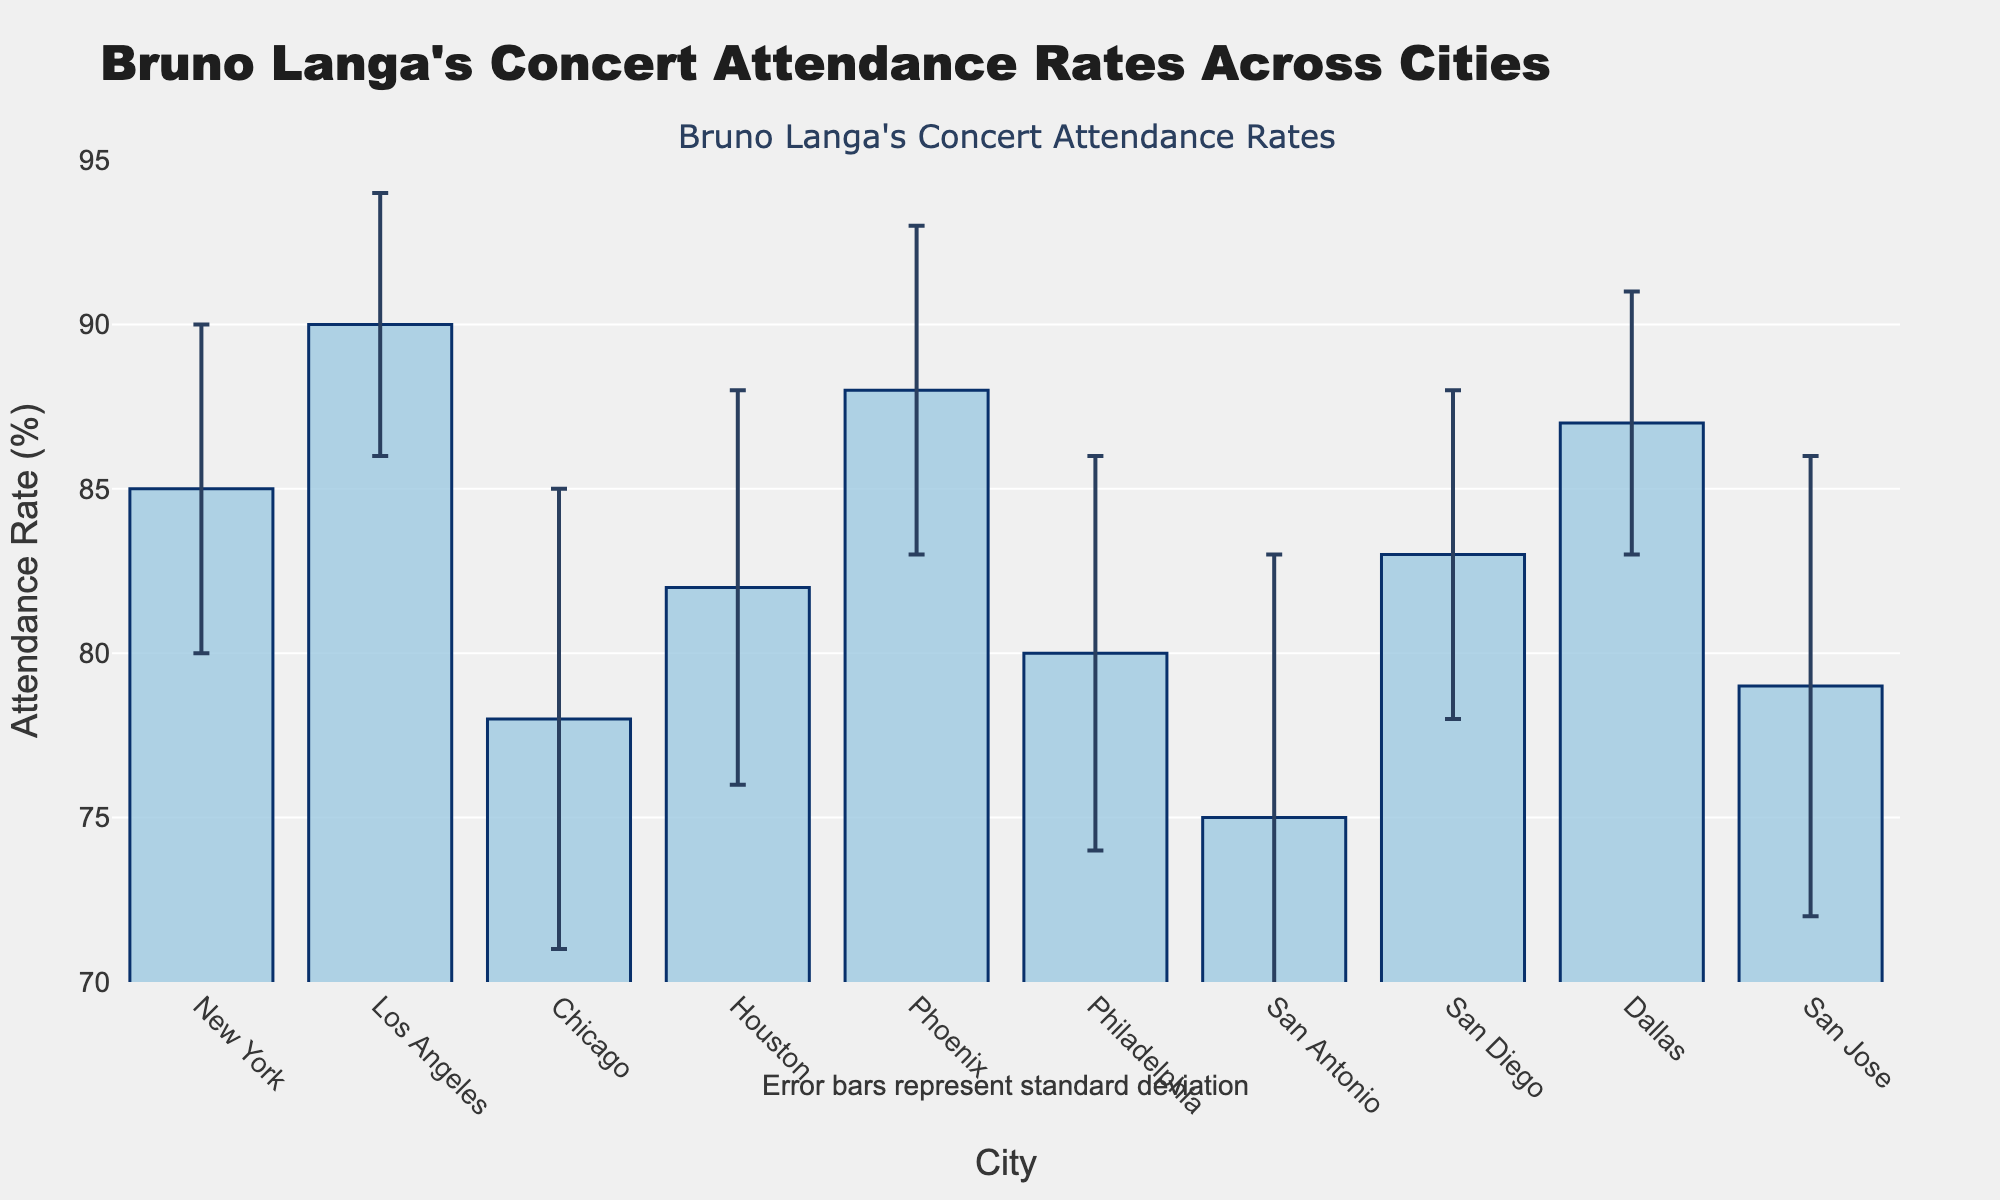question1: What is the title of the plot? The title of the plot is displayed at the top and reads "Bruno Langa's Concert Attendance Rates Across Cities."
Answer: Bruno Langa's Concert Attendance Rates Across Cities question2: How many cities are included in the plot? Each bar represents a different city, and counting the bars will give us the number of cities. There are 10 bars in the plot.
Answer: 10 question3: Which city has the highest attendance rate? By comparing the heights of the bars, the tallest bar corresponds to Los Angeles with an attendance rate of 90%.
Answer: Los Angeles question4: What is the range of the y-axis? The range of the y-axis is indicated by the y-ticks and spans from 70% to 95%.
Answer: 70 to 95 question5: What is the attendance rate in Chicago? Find the bar labeled "Chicago" and note the height of the bar, which corresponds to an attendance rate of 78%.
Answer: 78% question6: How do the attendance rates in Dallas and Phoenix compare? By analyzing the heights of the bars, Dallas has an attendance rate of 87% and Phoenix has an attendance rate of 88%. Phoenix has a higher rate than Dallas.
Answer: Phoenix has a higher rate than Dallas question7: What is the average attendance rate across all cities? Sum the attendance rates of all cities and divide by the number of cities: (85 + 90 + 78 + 82 + 88 + 80 + 75 + 83 + 87 + 79) / 10 = 82.7%
Answer: 82.7% question8: Which city has the largest standard deviation in attendance rate? The standard deviation is given by the error bars; the longest error bar is for San Antonio with a standard deviation of 8.
Answer: San Antonio question9: If Bruno Langa wants to plan his next concert in the city with the least variation in attendance, which city should he choose? The city with the shortest error bar has the least variation. This city is Los Angeles, with a standard deviation of 4.
Answer: Los Angeles question10: What does the annotation below the plot indicate? The annotation below the plot specifies that the error bars represent the standard deviation of attendance rates.
Answer: Error bars represent standard deviation 